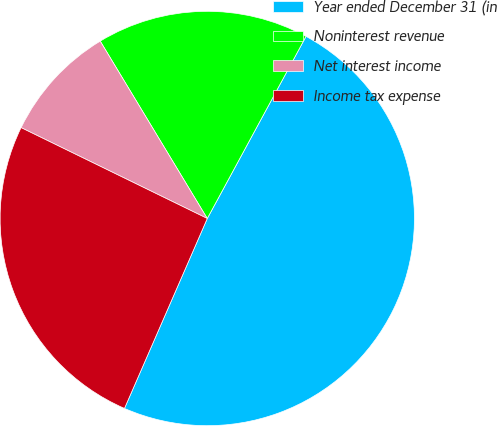<chart> <loc_0><loc_0><loc_500><loc_500><pie_chart><fcel>Year ended December 31 (in<fcel>Noninterest revenue<fcel>Net interest income<fcel>Income tax expense<nl><fcel>48.63%<fcel>16.55%<fcel>9.13%<fcel>25.68%<nl></chart> 